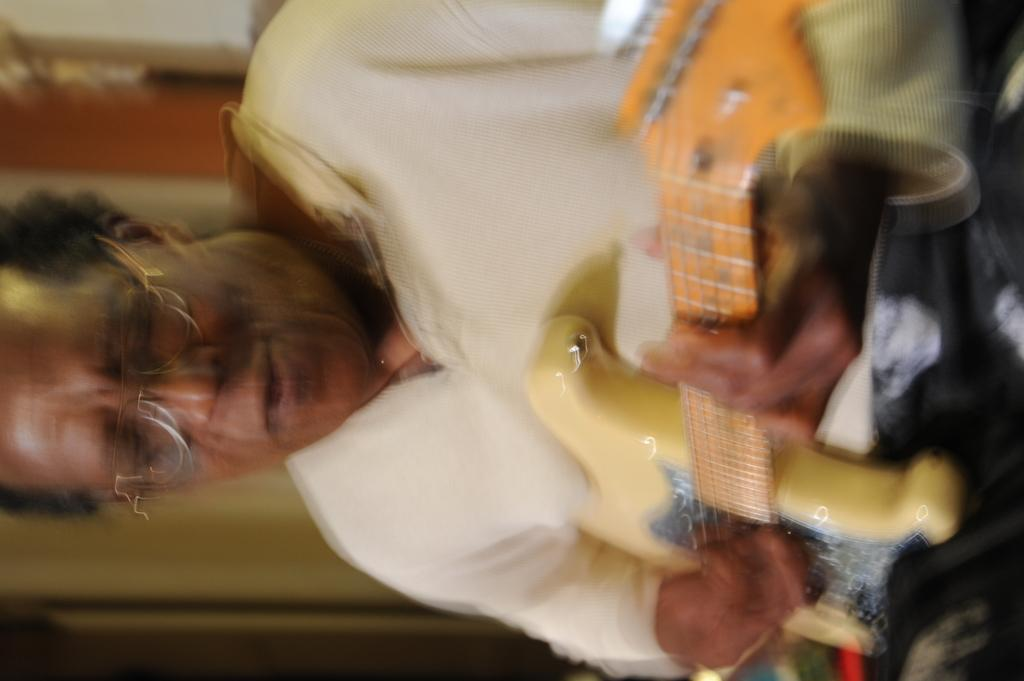What is the main subject of the image? There is a man in the image. What is the man wearing? The man is wearing a white t-shirt. What activity is the man engaged in? The man is playing a guitar. What type of engine can be seen in the image? There is no engine present in the image; it features a man playing a guitar. Can you describe the coastline visible in the image? There is no coastline visible in the image; it features a man playing a guitar. 